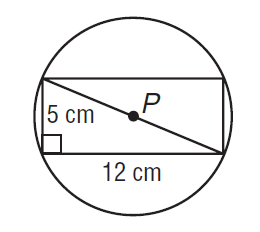Answer the mathemtical geometry problem and directly provide the correct option letter.
Question: Find the exact circumference of \odot P.
Choices: A: 13 B: 12 \pi C: 40.84 D: 13 \pi D 